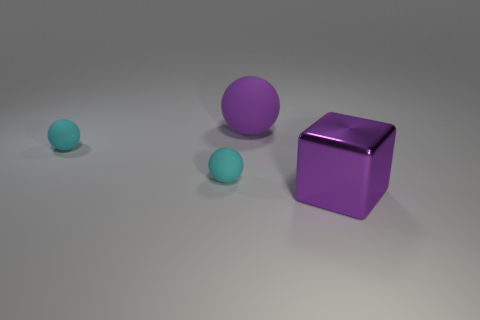What number of cyan rubber objects have the same shape as the big purple rubber thing? There are two cyan rubber spheres that share the same shape as the larger purple rubber cube. 